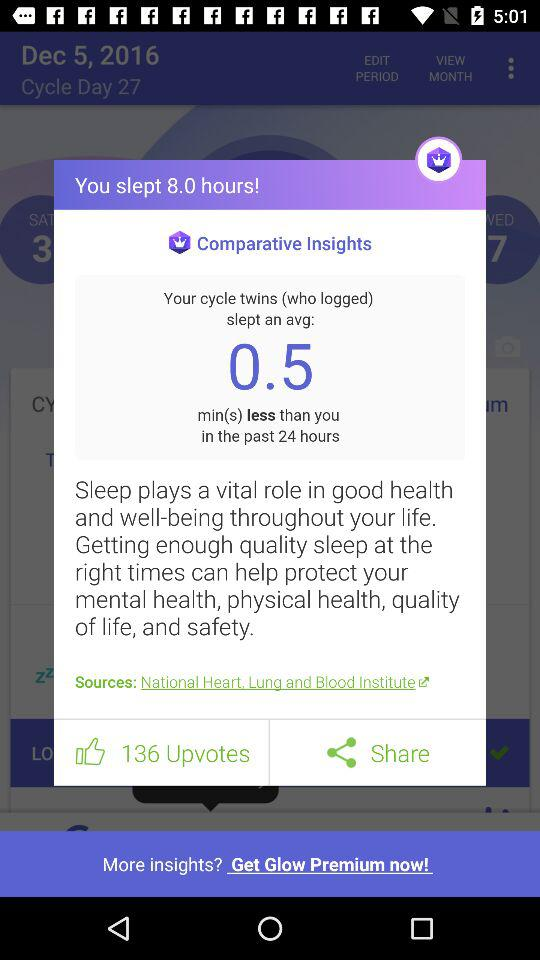How many upvotes does the post have?
Answer the question using a single word or phrase. 136 